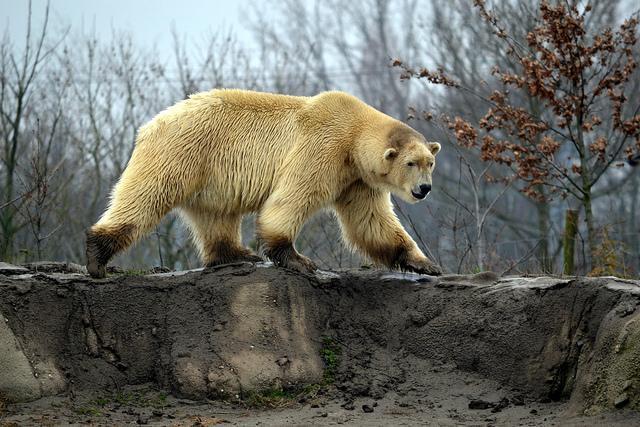How many bears are there?
Give a very brief answer. 1. 